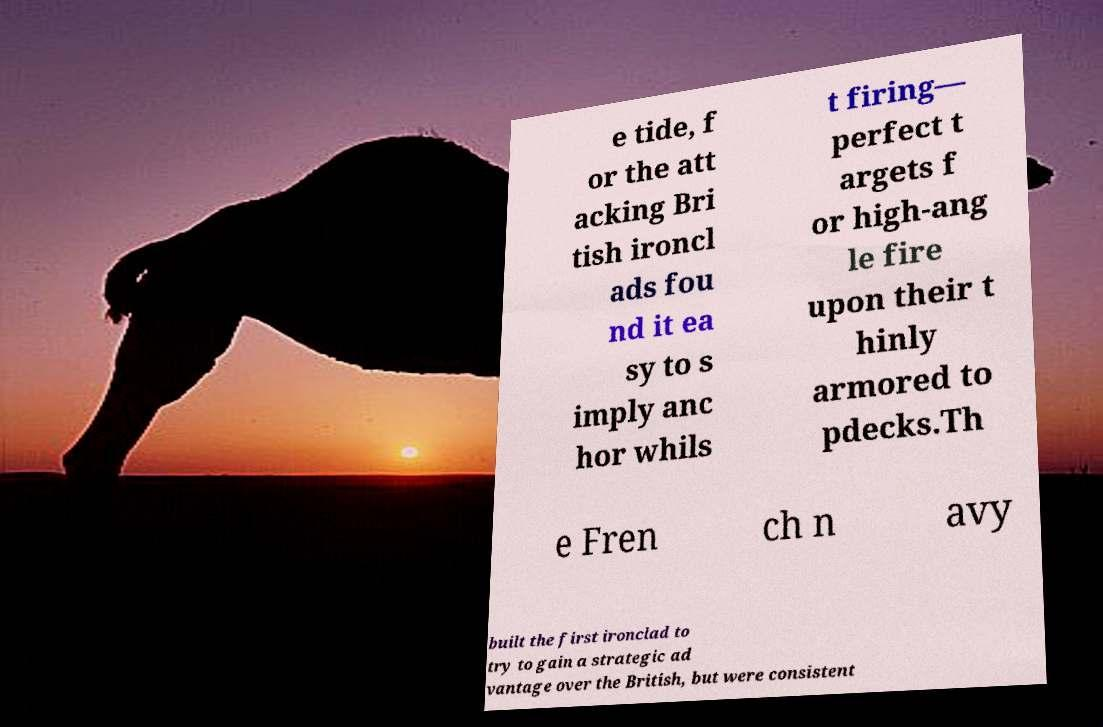Can you accurately transcribe the text from the provided image for me? e tide, f or the att acking Bri tish ironcl ads fou nd it ea sy to s imply anc hor whils t firing— perfect t argets f or high-ang le fire upon their t hinly armored to pdecks.Th e Fren ch n avy built the first ironclad to try to gain a strategic ad vantage over the British, but were consistent 